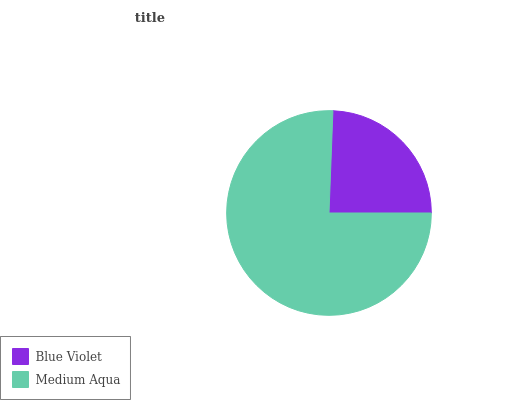Is Blue Violet the minimum?
Answer yes or no. Yes. Is Medium Aqua the maximum?
Answer yes or no. Yes. Is Medium Aqua the minimum?
Answer yes or no. No. Is Medium Aqua greater than Blue Violet?
Answer yes or no. Yes. Is Blue Violet less than Medium Aqua?
Answer yes or no. Yes. Is Blue Violet greater than Medium Aqua?
Answer yes or no. No. Is Medium Aqua less than Blue Violet?
Answer yes or no. No. Is Medium Aqua the high median?
Answer yes or no. Yes. Is Blue Violet the low median?
Answer yes or no. Yes. Is Blue Violet the high median?
Answer yes or no. No. Is Medium Aqua the low median?
Answer yes or no. No. 